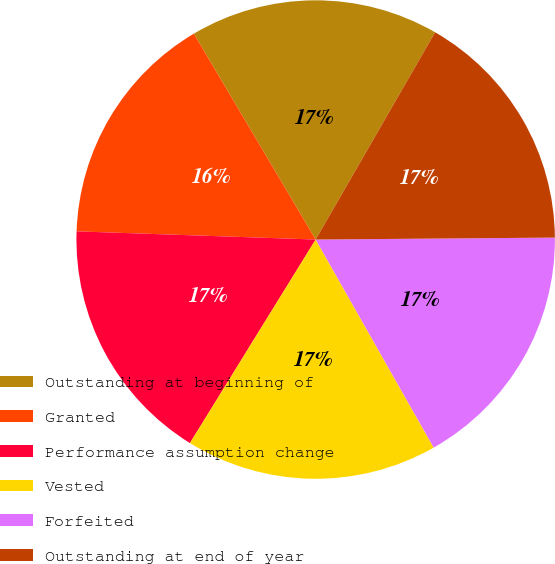<chart> <loc_0><loc_0><loc_500><loc_500><pie_chart><fcel>Outstanding at beginning of<fcel>Granted<fcel>Performance assumption change<fcel>Vested<fcel>Forfeited<fcel>Outstanding at end of year<nl><fcel>16.83%<fcel>15.95%<fcel>16.74%<fcel>17.02%<fcel>16.92%<fcel>16.55%<nl></chart> 